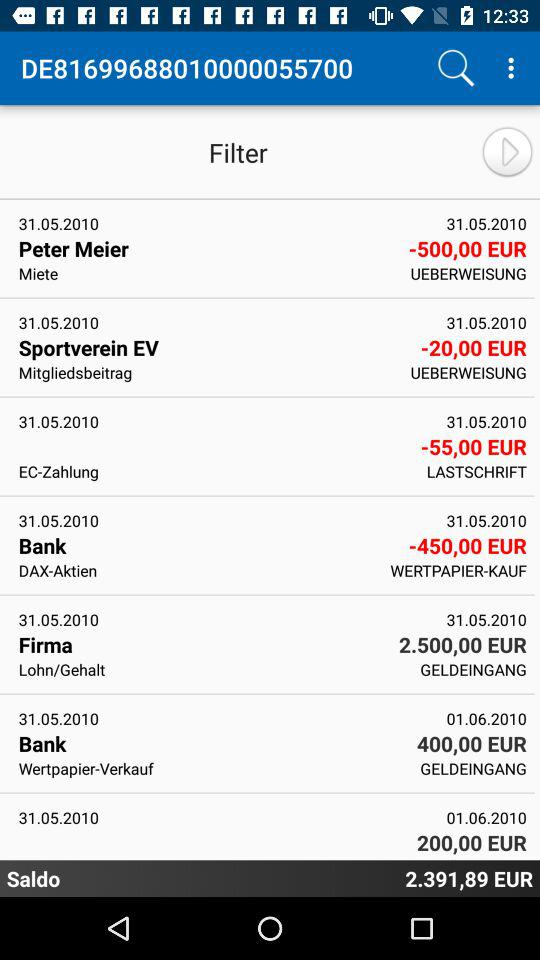What is the price mentioned for "Firma"? The mentioned price is 2.5 million euros. 